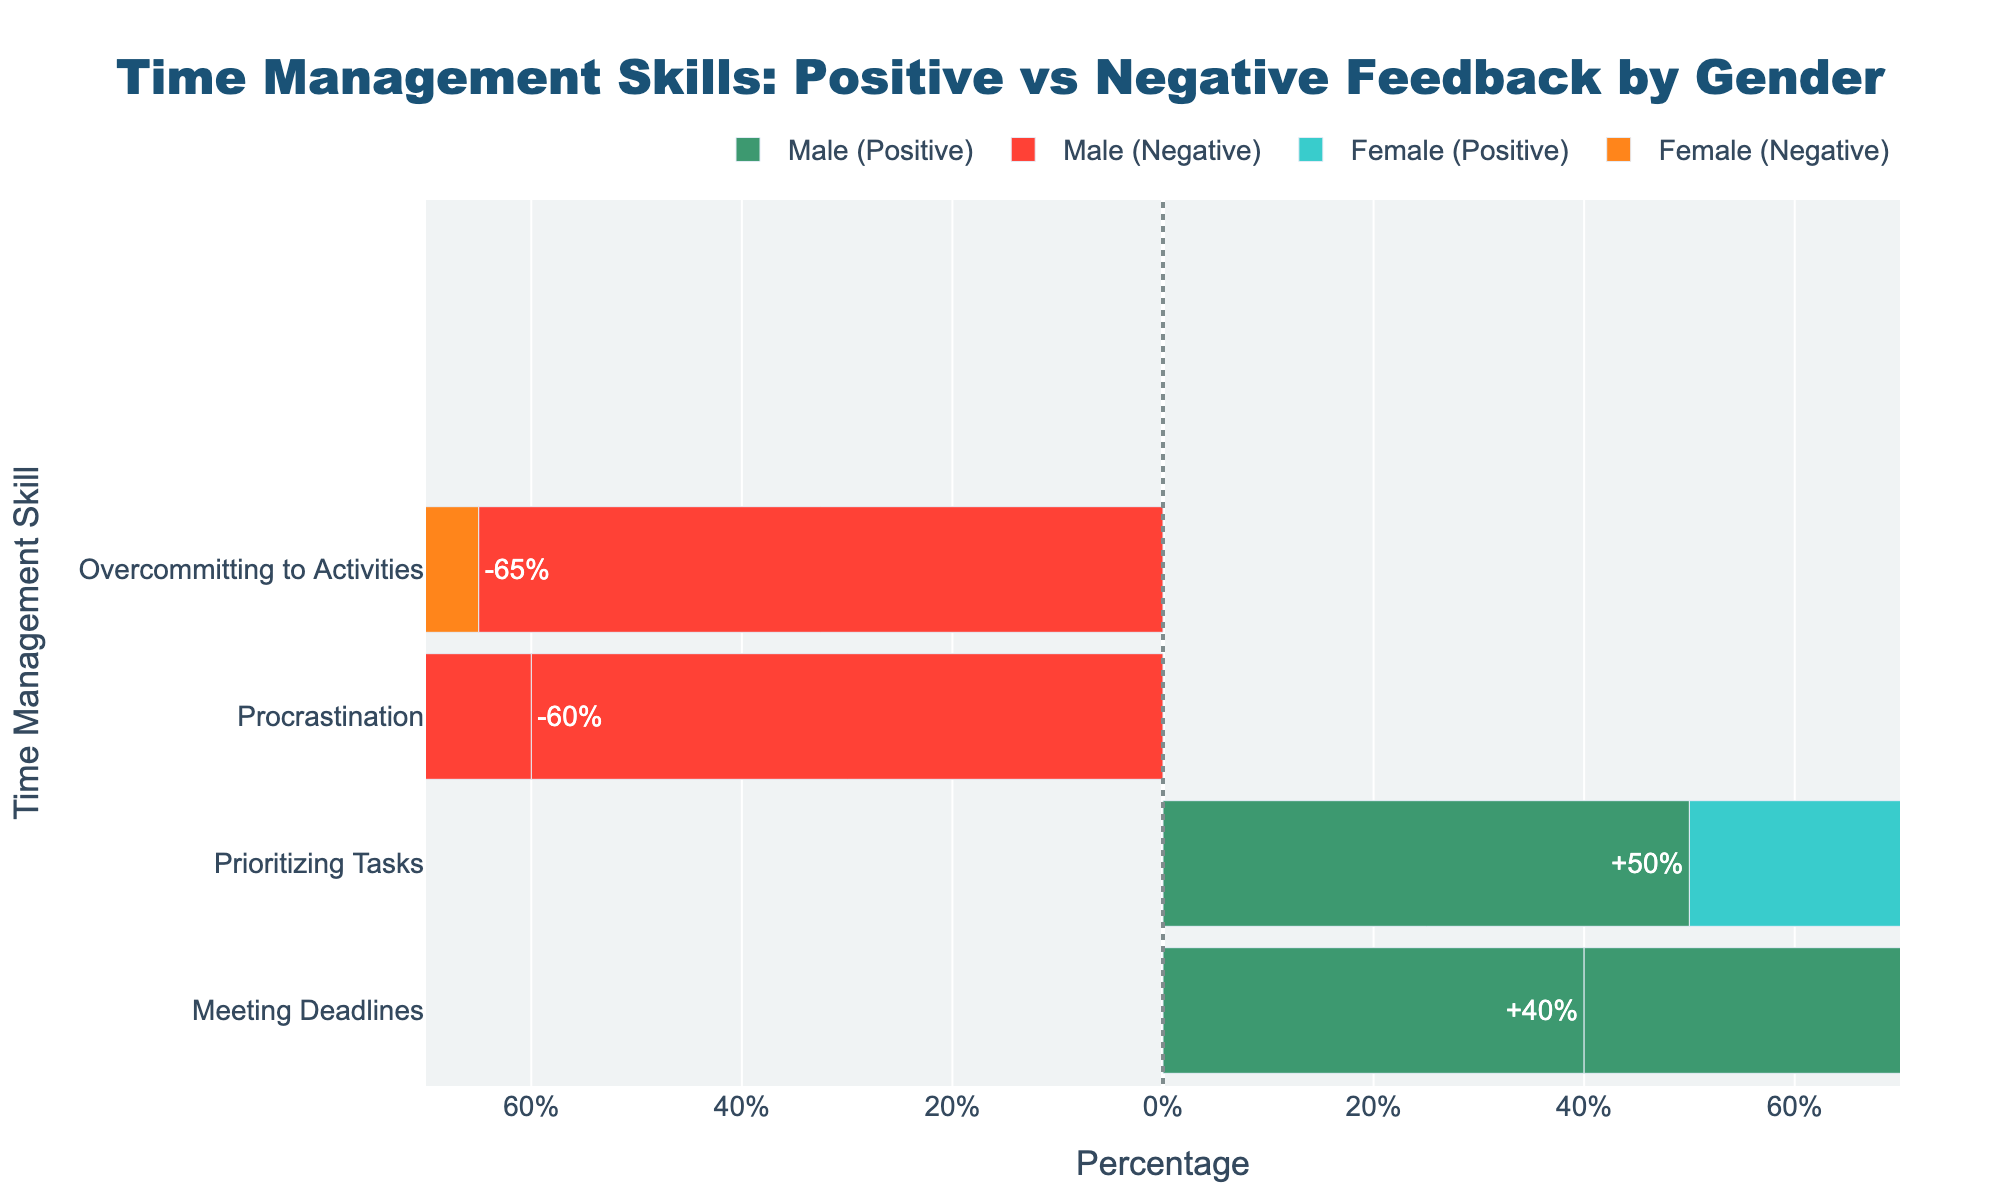What's the percentage difference between males and females for meeting deadlines with positive feedback? The bar chart shows that 40% of males and 60% of females receive positive feedback for meeting deadlines. The difference is calculated as 60% - 40% = 20%.
Answer: 20% Who receives more negative feedback for overcommitting to activities, males or females? The bar chart shows that 55% of males and 45% of females receive negative feedback for overcommitting to activities. Therefore, males receive more negative feedback.
Answer: Males In terms of prioritizing tasks, which gender has a higher percentage of positive feedback? The bar chart shows that 45% of males and 55% of females receive positive feedback for prioritizing tasks. Therefore, females have a higher percentage of positive feedback.
Answer: Females What is the overall percentage of positive feedback for consistent study habits between both genders? The chart indicates that both males and females have 50% positive feedback for consistent study habits. Adding these: 50% + 50% = 100%. This is the combined positive feedback percentage between both genders.
Answer: 100% Which gender has a lower percentage of negative feedback for ineffective planning? The bar chart shows that females receive 35% negative feedback, while males receive 65% negative feedback for ineffective planning. Therefore, females have a lower percentage of negative feedback.
Answer: Females What is the combined percentage of negative feedback for procrastination across both genders? The chart indicates that 60% of males and 40% of females receive negative feedback for procrastination. Adding these: 60% + 40% = 100%.
Answer: 100% Can you tell the most frequent time management skill issue faced by males and the respective negative feedback percentage? By examining the negative feedback bars, males receive the most negative feedback for ineffective planning with a percentage of 65%.
Answer: Ineffective planning, 65% Compare the positive feedback percentages between males and females for prioritizing tasks and derive the combined average percentage. The bar chart shows 45% of males and 55% of females receive positive feedback for prioritizing tasks. The combined average is calculated as (45% + 55%) / 2 = 50%.
Answer: 50% Is there any time management skill with equal positive feedback for both genders? If yes, which one? The bar chart indicates that consistent study habits have equal positive feedback of 50% for both males and females.
Answer: Consistent study habits 